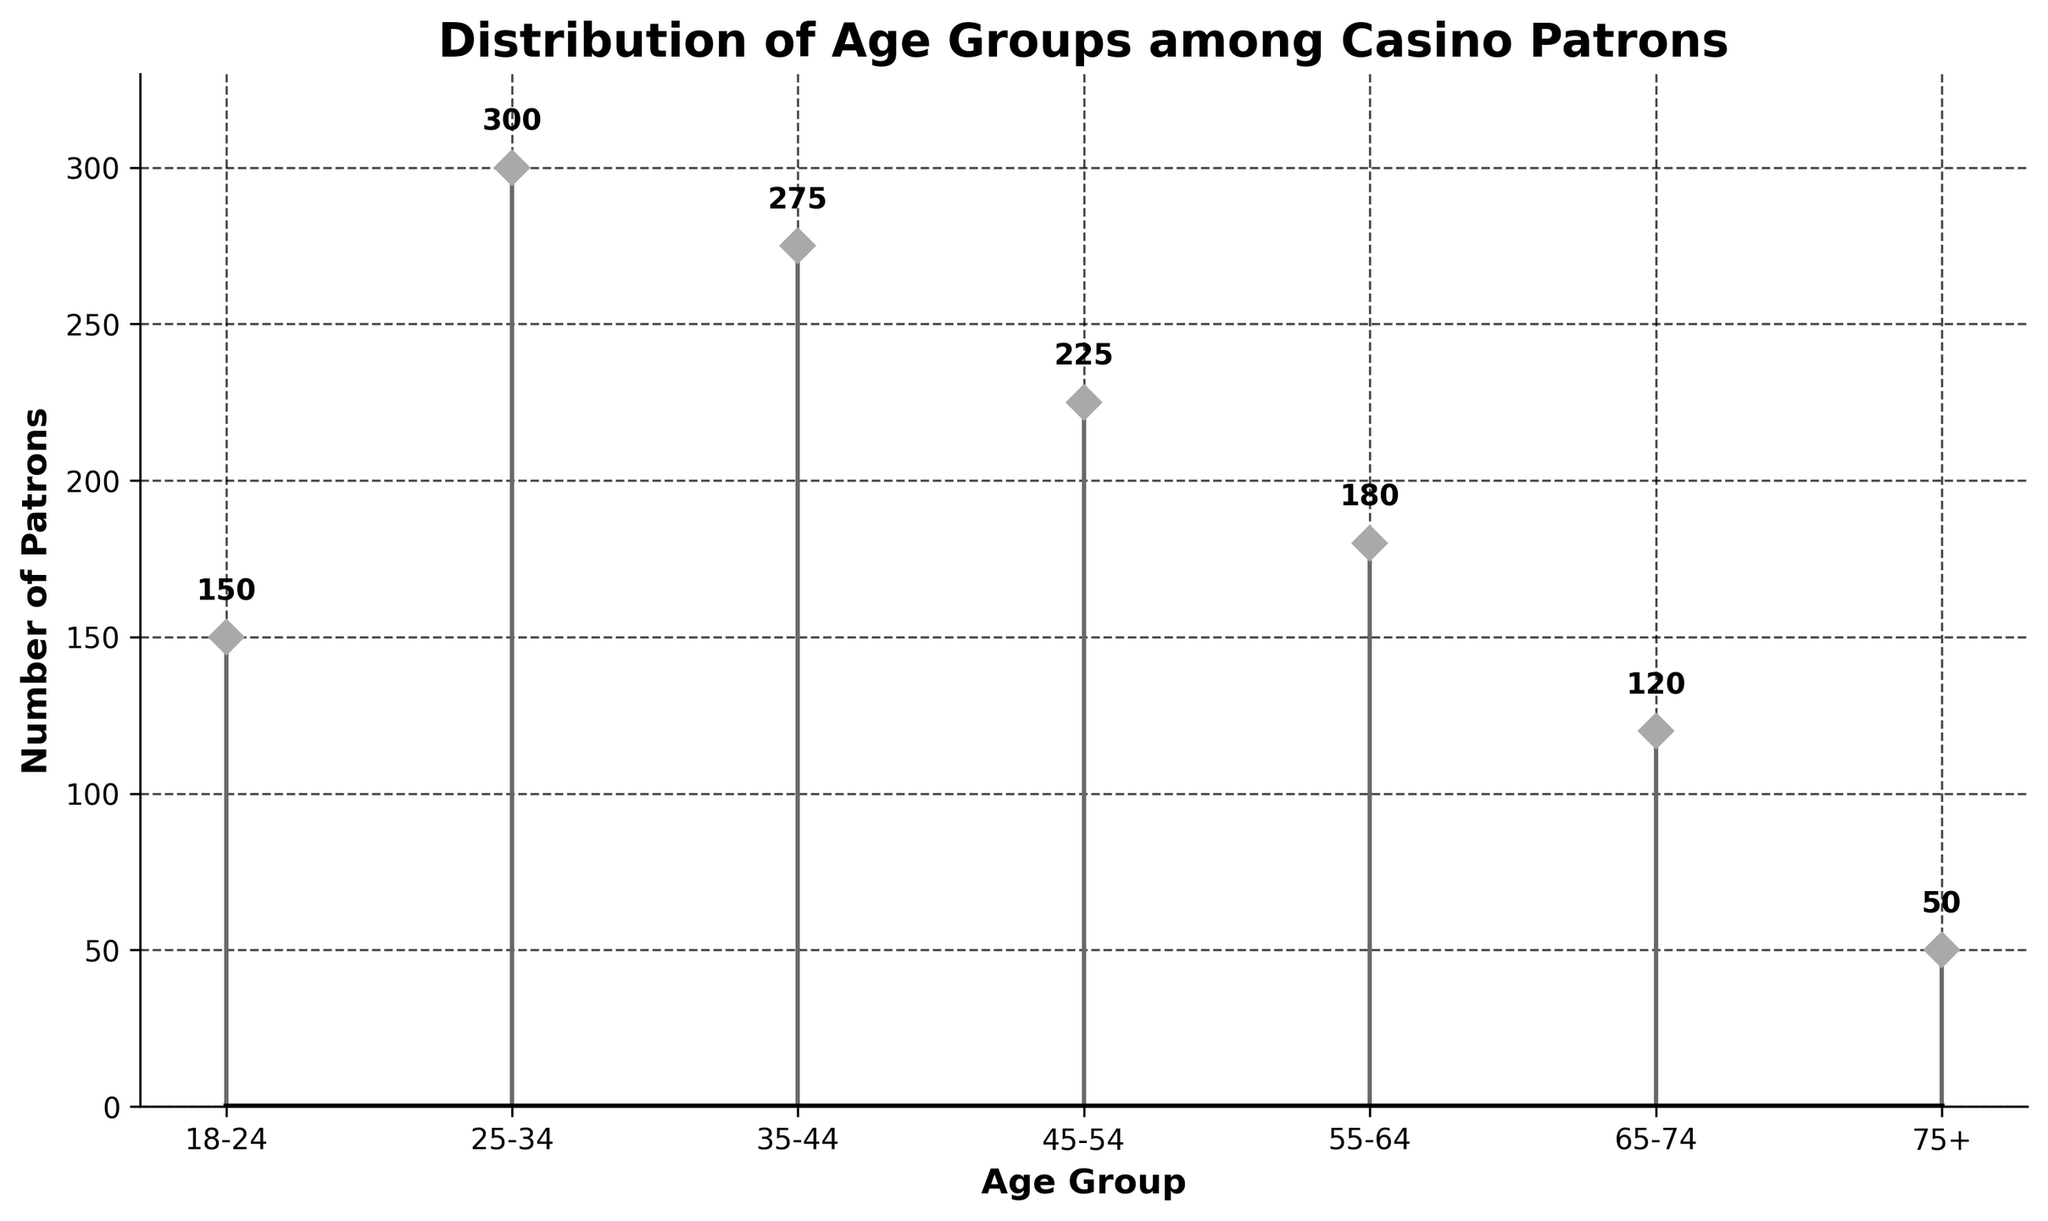What is the title of the plot? The title is generally located at the top of the plot. In this case, it reads 'Distribution of Age Groups among Casino Patrons'.
Answer: Distribution of Age Groups among Casino Patrons Which age group has the highest number of patrons? We identify the highest data point on the y-axis and match it to the corresponding x-axis label. The age group 25-34 has the tallest stem line, indicating the highest count of 300 patrons.
Answer: 25-34 What is the number of patrons in the 18-24 age group? By examining the stem corresponding to the 18-24 age group, we see it reaches up to 150 on the y-axis. The text annotation at the stem’s tip confirms the count.
Answer: 150 What is the total number of patrons represented in the plot? To find the total, sum all the counts for each age group: 150 + 300 + 275 + 225 + 180 + 120 + 50. This equals 1300.
Answer: 1300 How many age groups are shown in the plot? Count the number of distinct labels on the x-axis which represent different age groups. There are 7 age groups indicated.
Answer: 7 Which age group has the second lowest number of patrons? Identify the second shortest stem after the shortest one. The 75+ group has the lowest, and 65-74 has the next shortest stem with 120 patrons.
Answer: 65-74 What is the range of the number of patrons across all age groups? The range is calculated by subtracting the smallest value from the largest value. The highest count is 300 (25-34), and the lowest is 50 (75+). Thus, 300 - 50 = 250.
Answer: 250 How many more patrons are there in the 25-34 group compared to the 65-74 group? Subtract the count of the 65-74 group from the count of the 25-34 group. This is 300 - 120, hence 180 more patrons.
Answer: 180 Do any age groups have an equal count of patrons? We need to check all the counts for duplicates. Each count is unique in this plot, confirming no age groups have an identical number of patrons.
Answer: No What is the average number of patrons per age group? Add up all counts and divide by the number of age groups. The sum of patrons is 1300, divided by 7 age groups, results in an average of 185.71 patrons per age group.
Answer: 185.71 